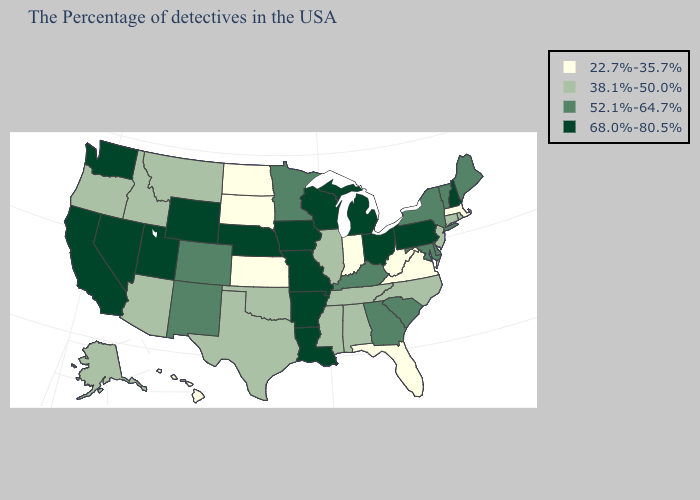What is the lowest value in the USA?
Write a very short answer. 22.7%-35.7%. What is the value of California?
Be succinct. 68.0%-80.5%. Among the states that border Wyoming , does Colorado have the lowest value?
Quick response, please. No. Name the states that have a value in the range 38.1%-50.0%?
Answer briefly. Rhode Island, Connecticut, New Jersey, North Carolina, Alabama, Tennessee, Illinois, Mississippi, Oklahoma, Texas, Montana, Arizona, Idaho, Oregon, Alaska. What is the lowest value in states that border Colorado?
Give a very brief answer. 22.7%-35.7%. Among the states that border Illinois , does Indiana have the lowest value?
Quick response, please. Yes. Name the states that have a value in the range 52.1%-64.7%?
Give a very brief answer. Maine, Vermont, New York, Delaware, Maryland, South Carolina, Georgia, Kentucky, Minnesota, Colorado, New Mexico. Which states have the lowest value in the West?
Concise answer only. Hawaii. Name the states that have a value in the range 68.0%-80.5%?
Give a very brief answer. New Hampshire, Pennsylvania, Ohio, Michigan, Wisconsin, Louisiana, Missouri, Arkansas, Iowa, Nebraska, Wyoming, Utah, Nevada, California, Washington. Does Ohio have the highest value in the USA?
Give a very brief answer. Yes. Name the states that have a value in the range 52.1%-64.7%?
Give a very brief answer. Maine, Vermont, New York, Delaware, Maryland, South Carolina, Georgia, Kentucky, Minnesota, Colorado, New Mexico. What is the value of Hawaii?
Quick response, please. 22.7%-35.7%. What is the highest value in the Northeast ?
Quick response, please. 68.0%-80.5%. Name the states that have a value in the range 38.1%-50.0%?
Be succinct. Rhode Island, Connecticut, New Jersey, North Carolina, Alabama, Tennessee, Illinois, Mississippi, Oklahoma, Texas, Montana, Arizona, Idaho, Oregon, Alaska. What is the lowest value in the USA?
Answer briefly. 22.7%-35.7%. 